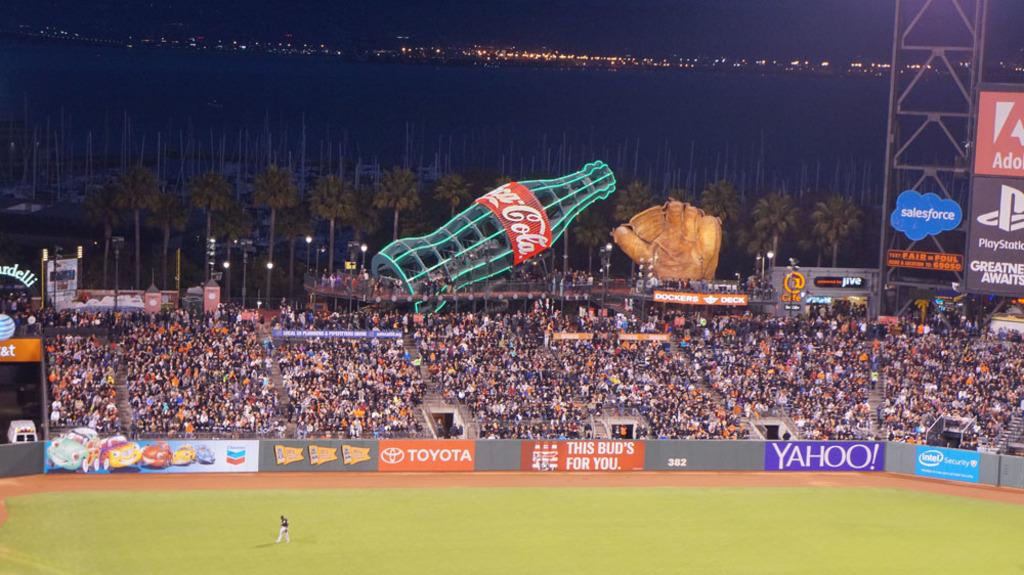Provide a one-sentence caption for the provided image. A huge illuminated coca cola bottle rises up behind a crowd of spectators in a sports stadium filled with advertising for Yahoo, Toyota and Play Station and many others. 